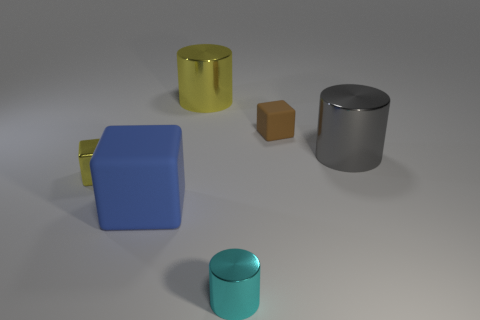Can you describe how the light interacts with the objects' surfaces? Certainly. The light source in the image creates soft shadows on the ground, indicating a diffused lighting environment. The glossy surfaces on the yellow mug and the teal cylinder reflect the light more brightly, giving them a shiny appearance. In contrast, the matte surfaces of the blue cube and the silver cylinder diffuse the light, providing a more subdued look with less pronounced reflections. 